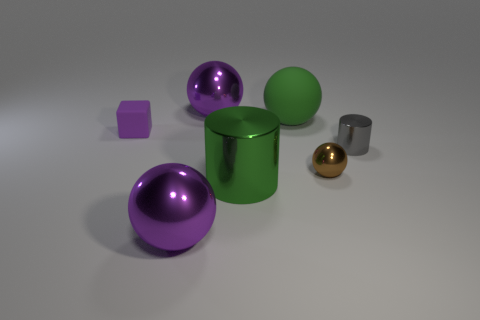Subtract all small spheres. How many spheres are left? 3 Add 1 large green balls. How many objects exist? 8 Subtract all yellow blocks. How many purple spheres are left? 2 Subtract all purple balls. How many balls are left? 2 Subtract all cylinders. How many objects are left? 5 Subtract all big blue shiny cylinders. Subtract all small brown metallic spheres. How many objects are left? 6 Add 3 large green matte objects. How many large green matte objects are left? 4 Add 6 small cubes. How many small cubes exist? 7 Subtract 0 cyan balls. How many objects are left? 7 Subtract 2 cylinders. How many cylinders are left? 0 